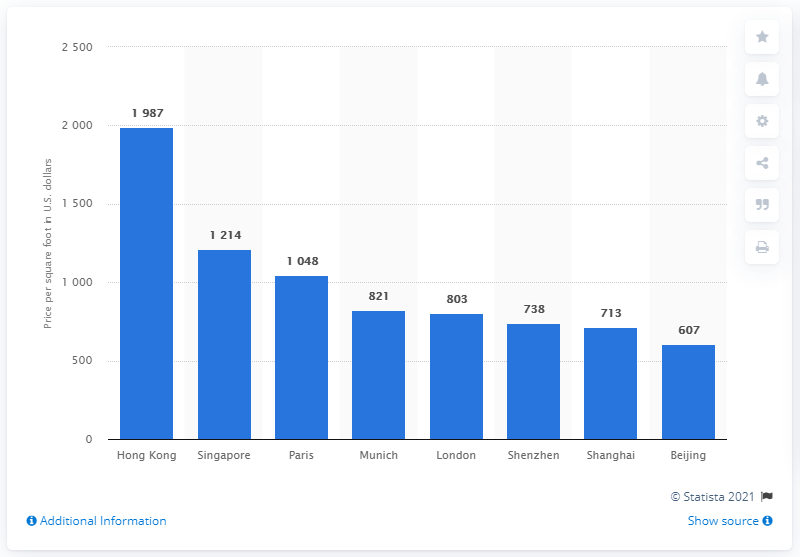Indicate a few pertinent items in this graphic. According to data from 2019, Hong Kong had the most expensive residential property market in the world. 